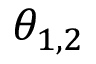<formula> <loc_0><loc_0><loc_500><loc_500>\theta _ { 1 , 2 }</formula> 